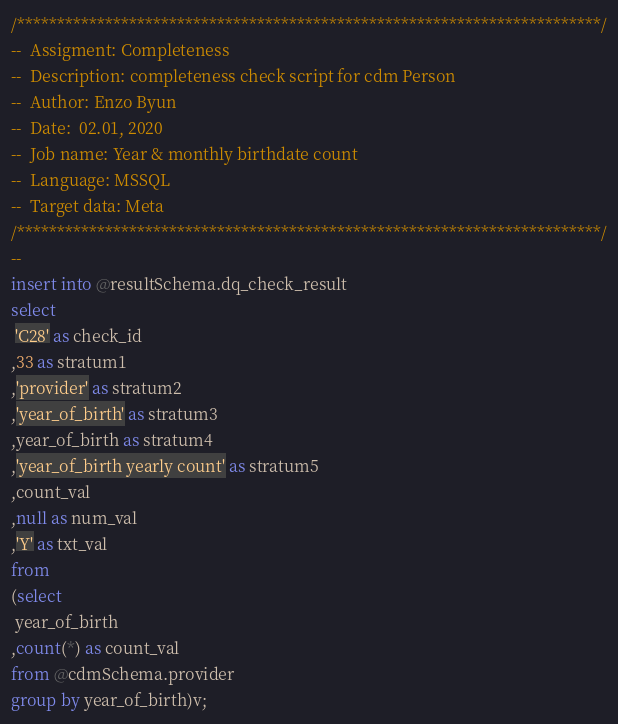Convert code to text. <code><loc_0><loc_0><loc_500><loc_500><_SQL_>/*************************************************************************/
--  Assigment: Completeness
--  Description: completeness check script for cdm Person
--  Author: Enzo Byun
--  Date:  02.01, 2020
--  Job name: Year & monthly birthdate count
--  Language: MSSQL
--  Target data: Meta
/*************************************************************************/
--
insert into @resultSchema.dq_check_result
select
 'C28' as check_id
,33 as stratum1
,'provider' as stratum2
,'year_of_birth' as stratum3
,year_of_birth as stratum4
,'year_of_birth yearly count' as stratum5
,count_val
,null as num_val
,'Y' as txt_val
from
(select
 year_of_birth
,count(*) as count_val
from @cdmSchema.provider
group by year_of_birth)v;

</code> 